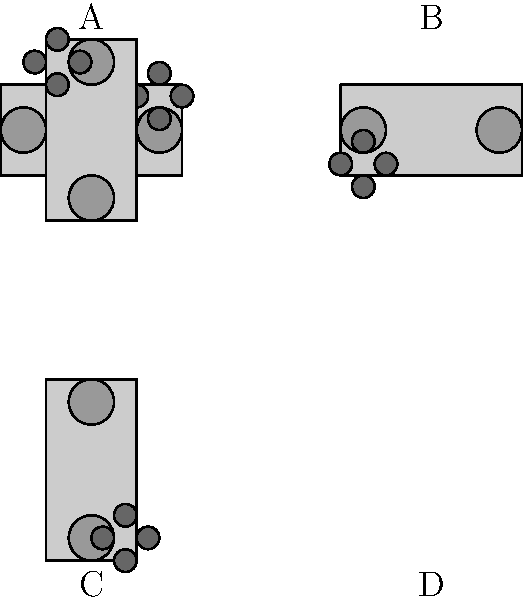In The Completionist's recent video review of a classic game, he demonstrated different controller orientations. Which image shows the correct rotation of the controller if it were rotated 270 degrees clockwise from its standard position? To determine the correct rotation of the controller, let's follow these steps:

1. Identify the standard position: The standard position of a game controller is typically with the analog sticks facing upwards and the buttons on the right side. This is represented by image A in our diagram.

2. Understand clockwise rotation: Clockwise rotation moves in the direction of a clock's hands, to the right.

3. Apply 270-degree rotation: A 270-degree clockwise rotation is equivalent to a 90-degree counterclockwise rotation. We can achieve this by rotating the controller three times by 90 degrees clockwise.

4. Follow the rotation:
   - 90 degrees clockwise: The controller would look like image B.
   - Another 90 degrees (180 total): The controller would look like image C.
   - Final 90 degrees (270 total): The controller would look like image D.

5. Verify the result: In image D, we can see that the analog sticks are now pointing to the left, and the buttons are at the bottom. This is indeed what the controller would look like after a 270-degree clockwise rotation.

Therefore, image D shows the correct rotation of the controller after a 270-degree clockwise rotation from its standard position.
Answer: D 